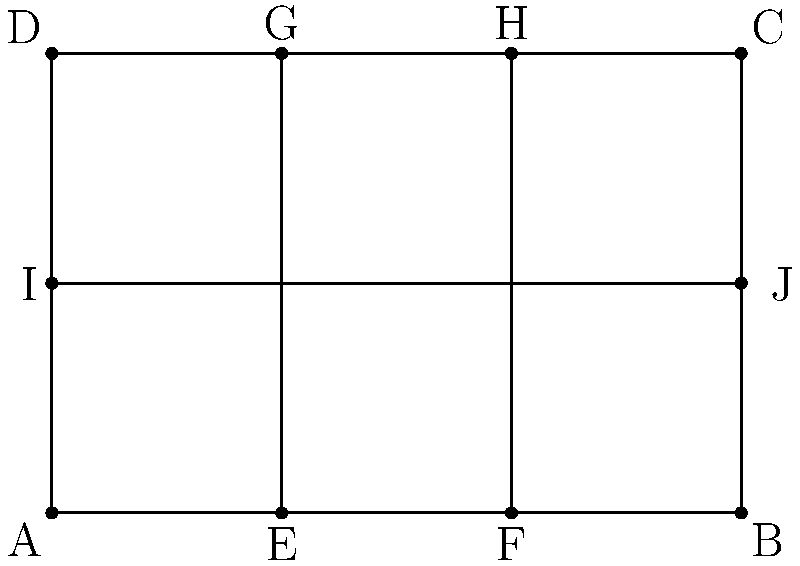In the floor plan of a traditional Russian izba shown above, the rectangular main room is divided into three sections by two parallel lines. If the total area of the floor plan is 24 square meters, what is the area of the central section in square meters? To solve this problem, we need to follow these steps:

1) First, let's identify the properties of the floor plan:
   - It's a rectangle divided into three sections by two parallel lines.
   - The divisions appear to be equal, creating three equal-width sections.

2) Let's denote the width of the entire rectangle as $w$ and its length as $l$.

3) We're given that the total area is 24 square meters. In mathematical terms:
   $$ A = w \times l = 24 \text{ m}^2 $$

4) From the diagram, we can see that the width is divided into three equal parts. Let's call the width of each section $x$. Then:
   $$ w = 3x $$

5) The central section's area will be $x \times l$.

6) To find $x$, we can use the total area equation:
   $$ 3x \times l = 24 $$

7) We don't know $l$, but we know that $l = \frac{24}{3x} = \frac{8}{x}$

8) Now, the area of the central section is:
   $$ A_{central} = x \times l = x \times \frac{8}{x} = 8 \text{ m}^2 $$

Therefore, the area of the central section is 8 square meters.
Answer: 8 square meters 